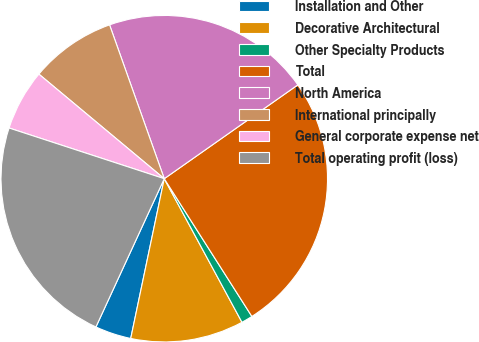<chart> <loc_0><loc_0><loc_500><loc_500><pie_chart><fcel>Installation and Other<fcel>Decorative Architectural<fcel>Other Specialty Products<fcel>Total<fcel>North America<fcel>International principally<fcel>General corporate expense net<fcel>Total operating profit (loss)<nl><fcel>3.58%<fcel>11.19%<fcel>1.12%<fcel>25.73%<fcel>20.69%<fcel>8.5%<fcel>6.04%<fcel>23.15%<nl></chart> 